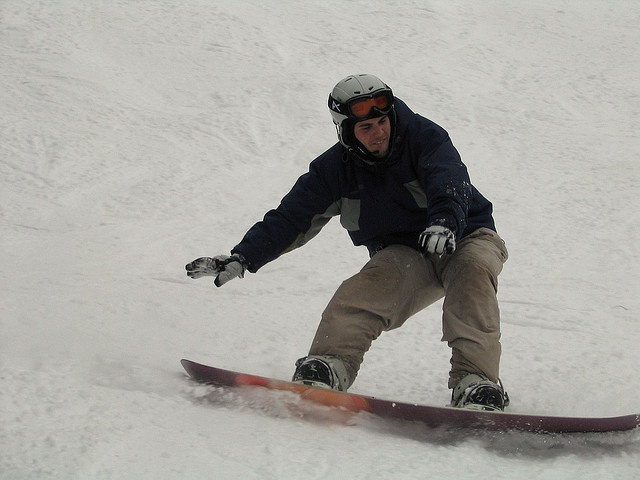Describe the objects in this image and their specific colors. I can see people in darkgray, black, and gray tones and snowboard in darkgray, black, gray, and brown tones in this image. 